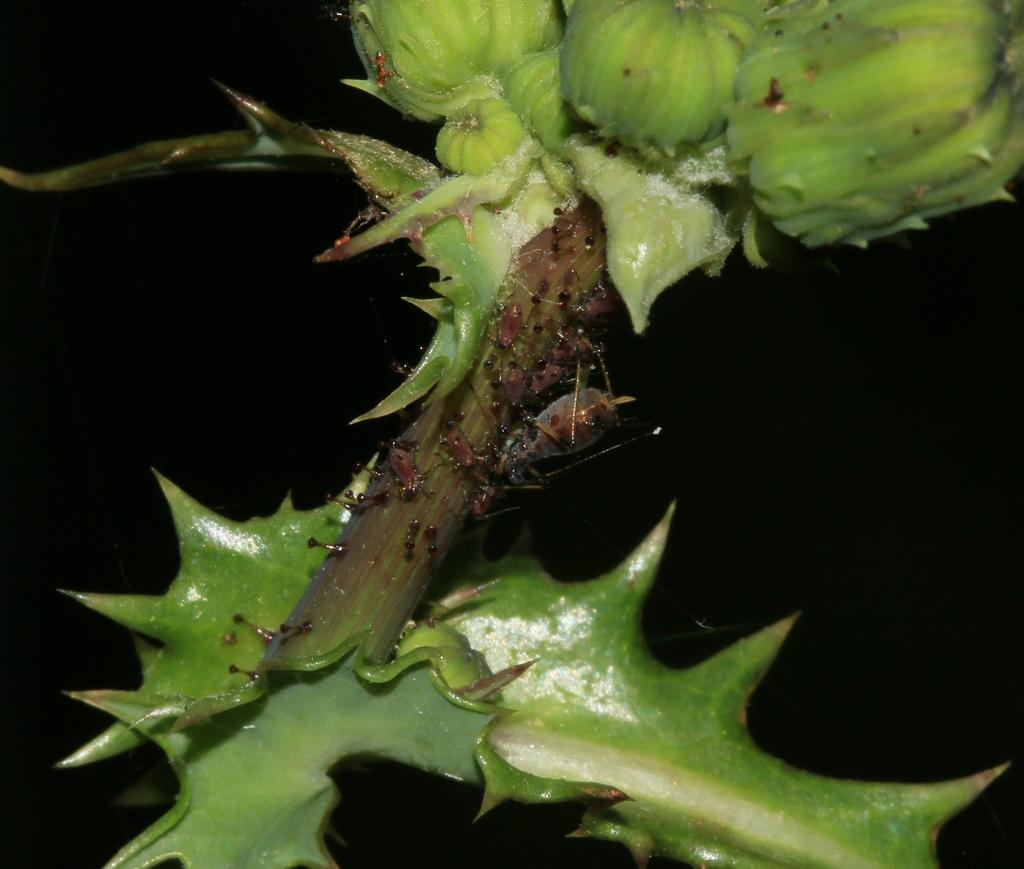What type of living organism is present in the image? There is a plant in the image. What stage of growth is the plant in? The plant has buds, indicating that it is in the process of blooming. Can you describe the leaf at the bottom of the plant? The leaf has thorns. What type of coat is the plant wearing in the image? There is no coat present in the image; the plant is not wearing any clothing. 